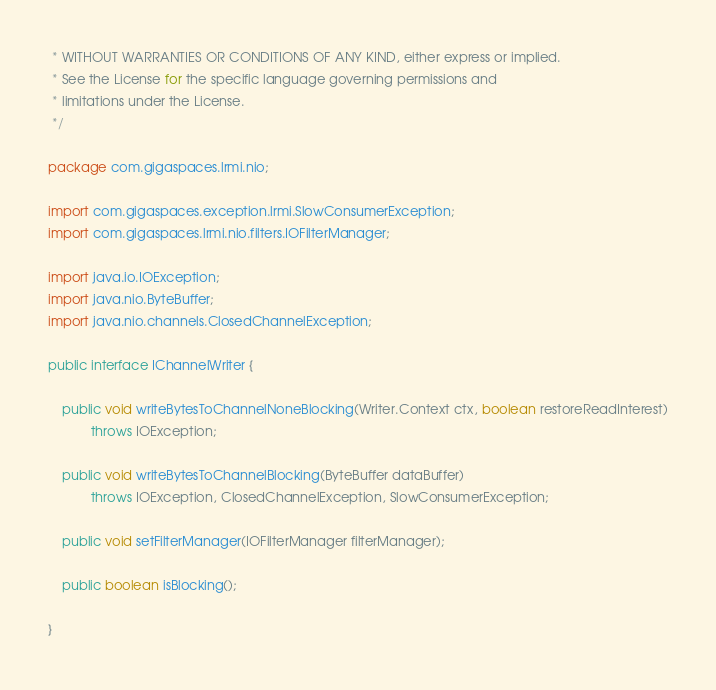Convert code to text. <code><loc_0><loc_0><loc_500><loc_500><_Java_> * WITHOUT WARRANTIES OR CONDITIONS OF ANY KIND, either express or implied.
 * See the License for the specific language governing permissions and
 * limitations under the License.
 */

package com.gigaspaces.lrmi.nio;

import com.gigaspaces.exception.lrmi.SlowConsumerException;
import com.gigaspaces.lrmi.nio.filters.IOFilterManager;

import java.io.IOException;
import java.nio.ByteBuffer;
import java.nio.channels.ClosedChannelException;

public interface IChannelWriter {

    public void writeBytesToChannelNoneBlocking(Writer.Context ctx, boolean restoreReadInterest)
            throws IOException;

    public void writeBytesToChannelBlocking(ByteBuffer dataBuffer)
            throws IOException, ClosedChannelException, SlowConsumerException;

    public void setFilterManager(IOFilterManager filterManager);

    public boolean isBlocking();

}</code> 